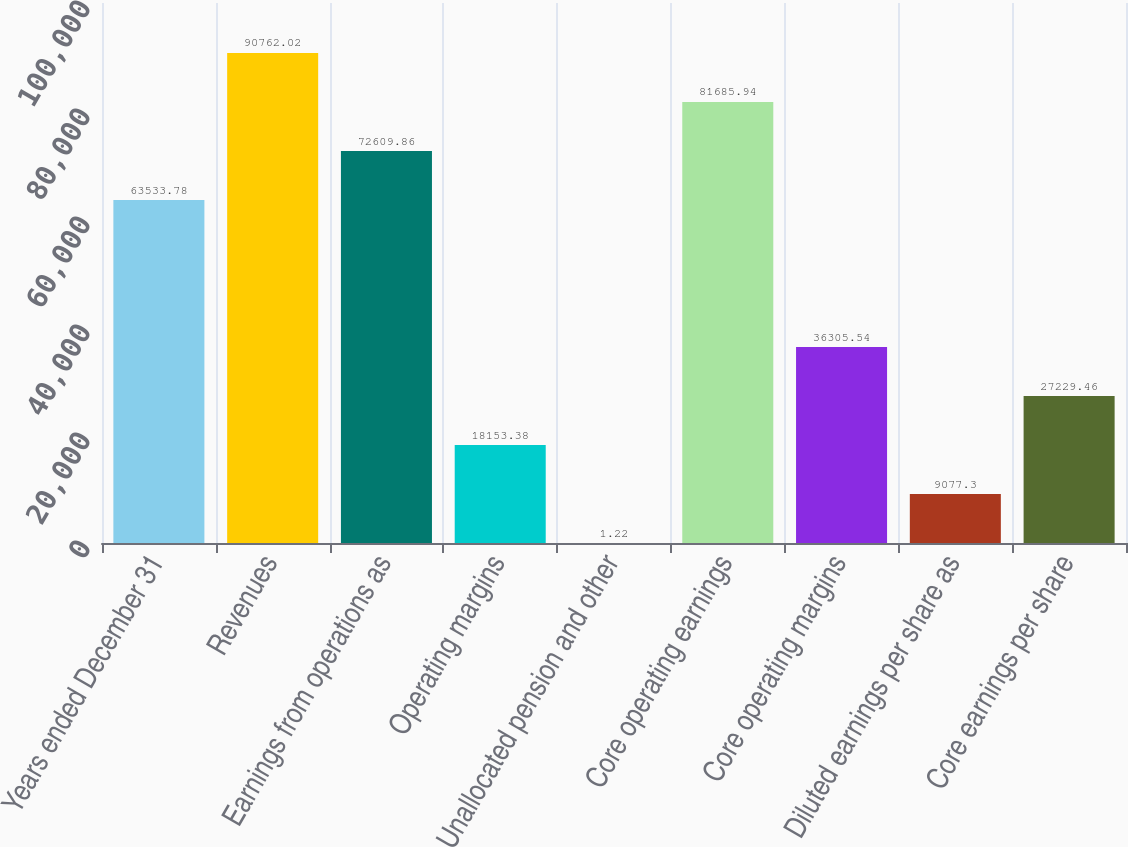<chart> <loc_0><loc_0><loc_500><loc_500><bar_chart><fcel>Years ended December 31<fcel>Revenues<fcel>Earnings from operations as<fcel>Operating margins<fcel>Unallocated pension and other<fcel>Core operating earnings<fcel>Core operating margins<fcel>Diluted earnings per share as<fcel>Core earnings per share<nl><fcel>63533.8<fcel>90762<fcel>72609.9<fcel>18153.4<fcel>1.22<fcel>81685.9<fcel>36305.5<fcel>9077.3<fcel>27229.5<nl></chart> 